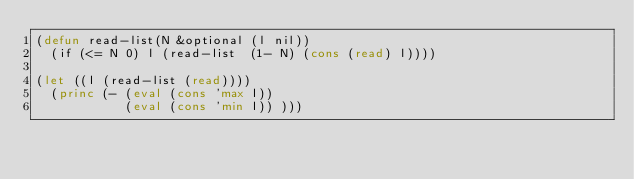<code> <loc_0><loc_0><loc_500><loc_500><_Lisp_>(defun read-list(N &optional (l nil))
  (if (<= N 0) l (read-list  (1- N) (cons (read) l))))

(let ((l (read-list (read))))
  (princ (- (eval (cons 'max l))
            (eval (cons 'min l)) )))</code> 